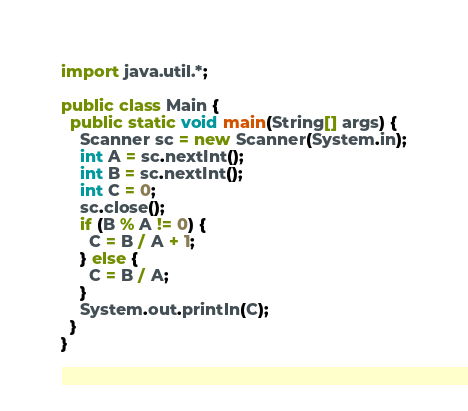Convert code to text. <code><loc_0><loc_0><loc_500><loc_500><_Java_>import java.util.*;

public class Main {
  public static void main(String[] args) {
    Scanner sc = new Scanner(System.in);
    int A = sc.nextInt();
    int B = sc.nextInt();
    int C = 0;
    sc.close();
    if (B % A != 0) {
      C = B / A + 1;
    } else {
      C = B / A;
    }
    System.out.println(C);
  }
}
</code> 